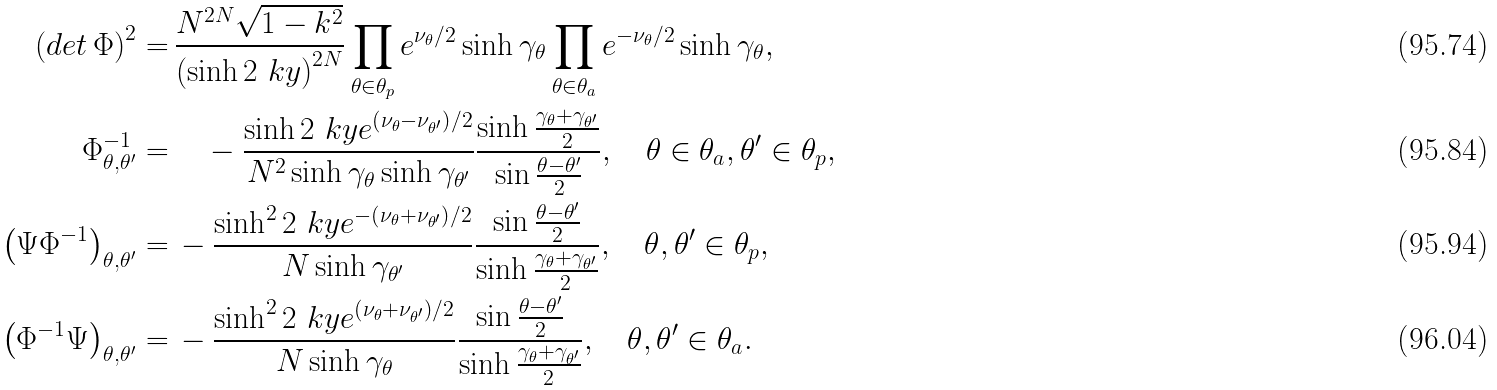Convert formula to latex. <formula><loc_0><loc_0><loc_500><loc_500>\left ( d e t \, \Phi \right ) ^ { 2 } = & \, \frac { N ^ { 2 N } \sqrt { 1 - k ^ { 2 } } } { \left ( \sinh 2 \ k y \right ) ^ { 2 N } } \prod _ { \theta \in \theta _ { p } } e ^ { \nu _ { \theta } / 2 } \sinh \gamma _ { \theta } \prod _ { \theta \in \theta _ { a } } e ^ { - \nu _ { \theta } / 2 } \sinh \gamma _ { \theta } , \\ \Phi ^ { - 1 } _ { \theta , \theta ^ { \prime } } = & \, \quad - \frac { \sinh 2 \ k y e ^ { \left ( \nu _ { \theta } - \nu _ { \theta ^ { \prime } } \right ) / 2 } } { N ^ { 2 } \sinh \gamma _ { \theta } \sinh \gamma _ { \theta ^ { \prime } } } \frac { \sinh \frac { \gamma _ { \theta } + \gamma _ { \theta ^ { \prime } } } { 2 } } { \sin \frac { \theta - \theta ^ { \prime } } { 2 } } , \quad \theta \in \theta _ { a } , \theta ^ { \prime } \in \theta _ { p } , \\ \left ( \Psi \Phi ^ { - 1 } \right ) _ { \theta , \theta ^ { \prime } } = & \, - \frac { \sinh ^ { 2 } 2 \ k y e ^ { - \left ( \nu _ { \theta } + \nu _ { \theta ^ { \prime } } \right ) / 2 } } { N \sinh \gamma _ { \theta ^ { \prime } } } \frac { \sin \frac { \theta - \theta ^ { \prime } } { 2 } } { \sinh \frac { \gamma _ { \theta } + \gamma _ { \theta ^ { \prime } } } { 2 } } , \quad \theta , \theta ^ { \prime } \in \theta _ { p } , \\ \left ( \Phi ^ { - 1 } \Psi \right ) _ { \theta , \theta ^ { \prime } } = & \, - \frac { \sinh ^ { 2 } 2 \ k y e ^ { \left ( \nu _ { \theta } + \nu _ { \theta ^ { \prime } } \right ) / 2 } } { N \sinh \gamma _ { \theta } } \frac { \sin \frac { \theta - \theta ^ { \prime } } { 2 } } { \sinh \frac { \gamma _ { \theta } + \gamma _ { \theta ^ { \prime } } } { 2 } } , \quad \theta , \theta ^ { \prime } \in \theta _ { a } .</formula> 